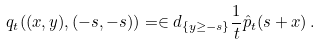Convert formula to latex. <formula><loc_0><loc_0><loc_500><loc_500>q _ { t } ( ( x , y ) , ( - s , - s ) ) = \in d _ { \{ y \geq - s \} } \frac { 1 } { t } \hat { p } _ { t } ( s + x ) \, .</formula> 